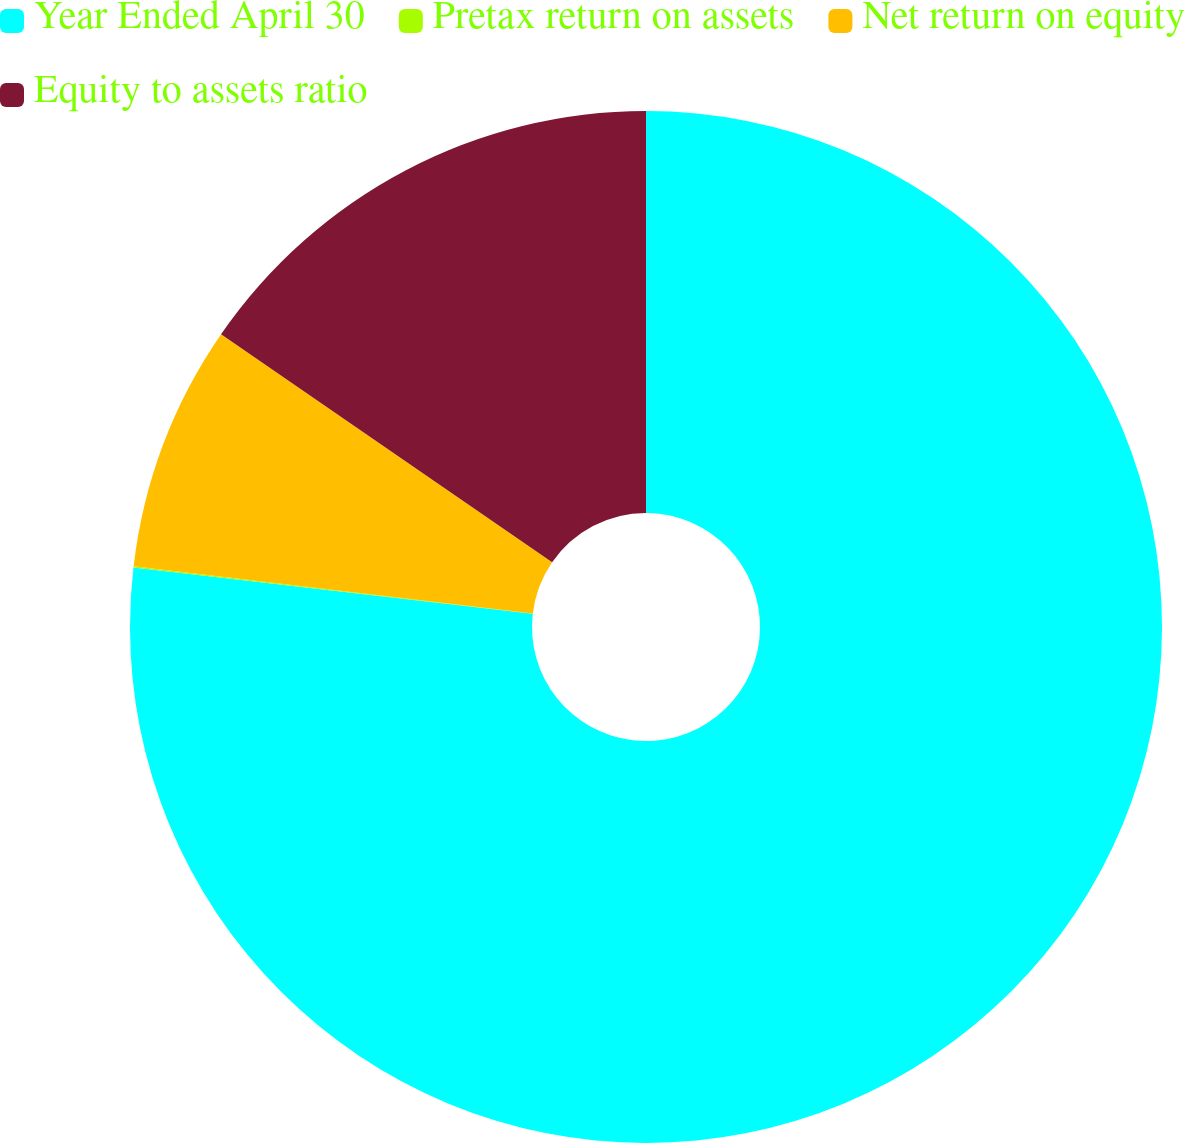<chart> <loc_0><loc_0><loc_500><loc_500><pie_chart><fcel>Year Ended April 30<fcel>Pretax return on assets<fcel>Net return on equity<fcel>Equity to assets ratio<nl><fcel>76.84%<fcel>0.04%<fcel>7.72%<fcel>15.4%<nl></chart> 